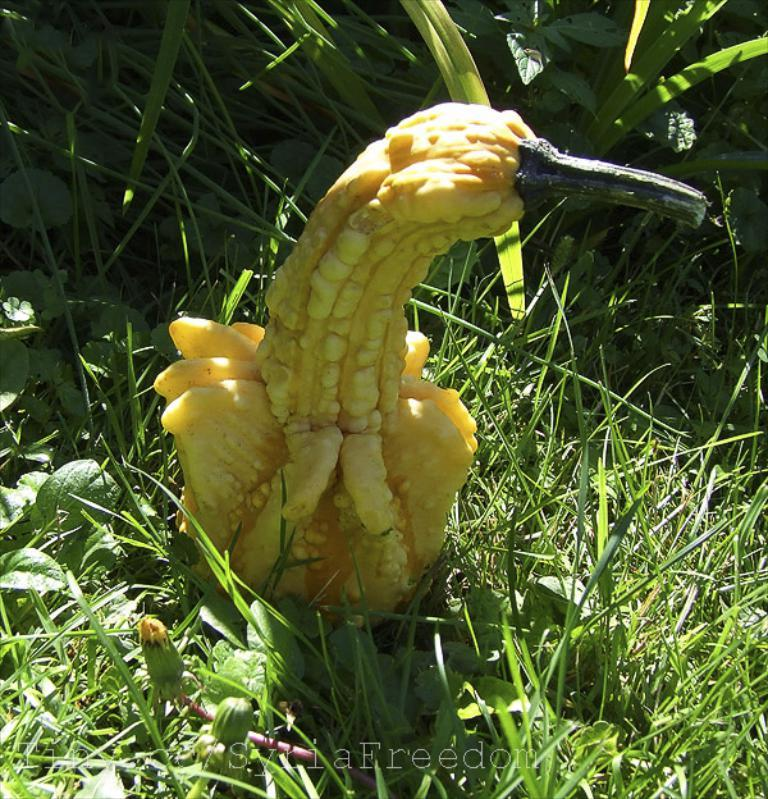What type of vegetable is present in the image? There is vegetable in the image, but the specific type cannot be determined from the provided facts. What type of vegetation is visible in the image? There is grass and plants visible in the image. What type of noise can be heard coming from the vegetable in the image? There is no indication in the image that the vegetable is making any noise, as vegetables do not have the ability to produce sound. 